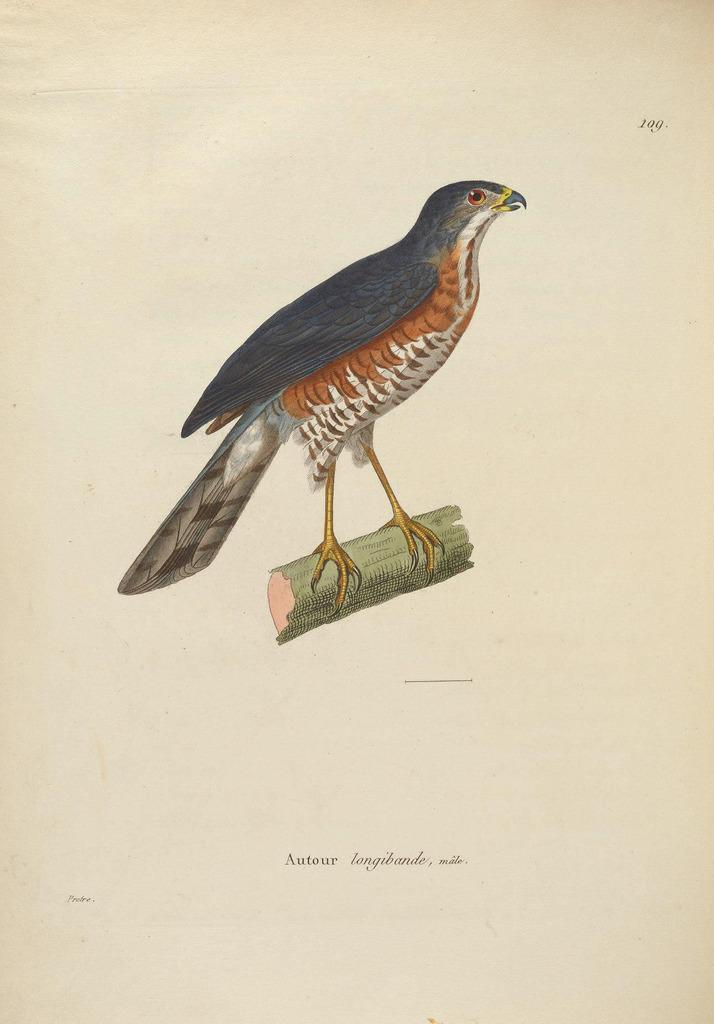What type of animal is in the image? There is a bird in the image. Where is the bird located? The bird is on a wooden log. Is there any text in the image? Yes, there is edited text in the image. What type of humor can be seen in the image? There is no humor present in the image; it features a bird on a wooden log and edited text. 